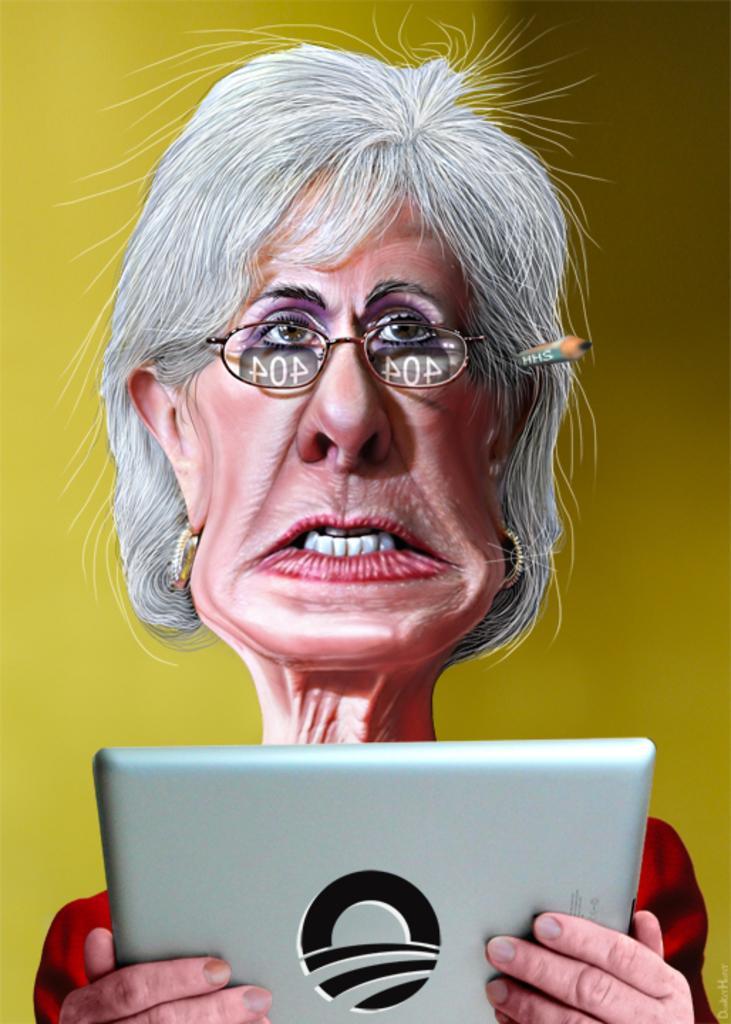Could you give a brief overview of what you see in this image? This is an animated image. In this image, in the middle, we can see a woman holding an electronic instrument. In the background, we can see yellow color. 